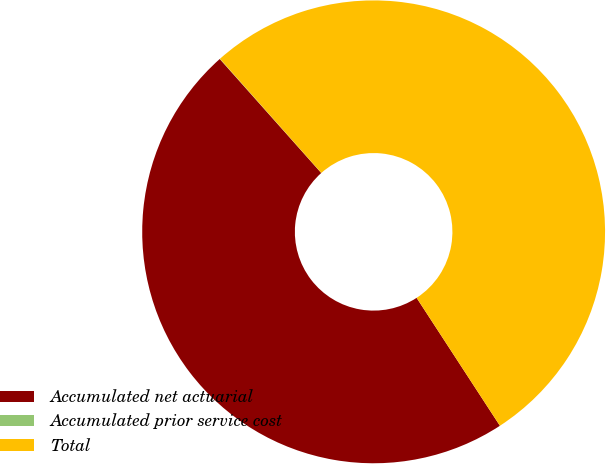<chart> <loc_0><loc_0><loc_500><loc_500><pie_chart><fcel>Accumulated net actuarial<fcel>Accumulated prior service cost<fcel>Total<nl><fcel>47.61%<fcel>0.02%<fcel>52.37%<nl></chart> 